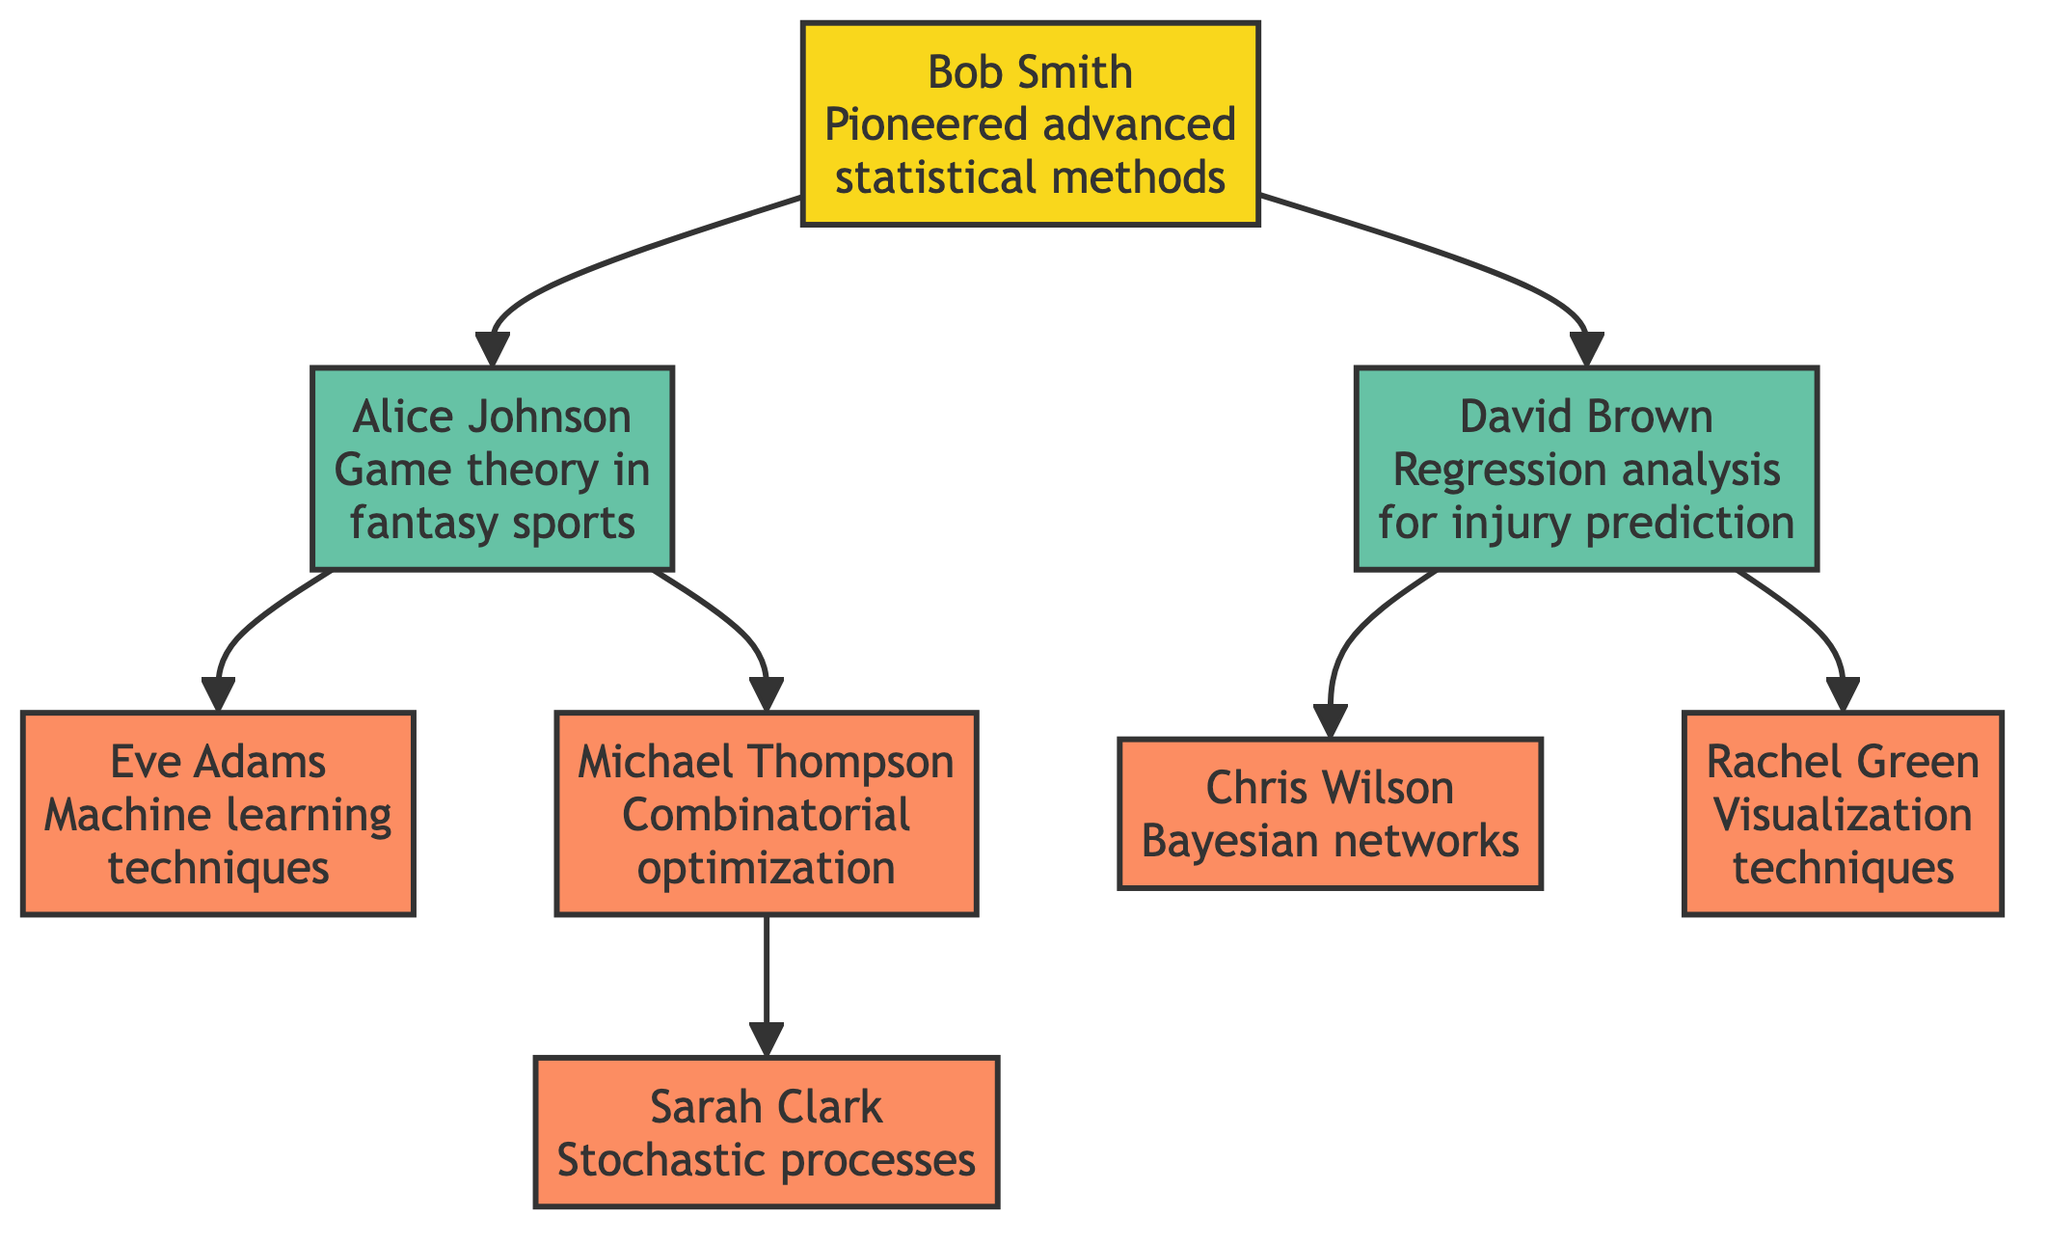What is the primary contribution of Alice Johnson? Alice Johnson is noted for authoring a widely-referenced playbook on game theory in fantasy sports.
Answer: Game theory in fantasy sports How many mentees does Bob Smith have? Bob Smith mentors two analysts: Alice Johnson and David Brown. Thus, he has a total of two mentees.
Answer: 2 Who developed models to forecast athlete injury probabilities? The diagram shows that David Brown specialized in regression analysis for injury prediction, indicating he developed these models.
Answer: David Brown What type of techniques did Eve Adams integrate into her predictions? Eve Adams is known for integrating machine learning techniques into her fantasy football predictions.
Answer: Machine learning techniques Which analyst focused on optimal lineup combinations and what method did they use? Michael Thompson focused on optimal lineup combinations using combinatorial optimization methods as indicated in the diagram.
Answer: Combinatorial optimization How many analysts did Alice Johnson mentor? Alice Johnson mentored two analysts: Eve Adams and Michael Thompson, as per the relationships shown in the diagram.
Answer: 2 What kind of analysis did Chris Wilson implement for decision making? The diagram indicates that Chris Wilson implemented Bayesian networks for fantasy football decision making.
Answer: Bayesian networks Who are the two analysts mentored by Bob Smith? Bob Smith mentored Alice Johnson and David Brown, which can be traced back through the directed lines in the diagram.
Answer: Alice Johnson, David Brown Which analyst introduced Monte Carlo simulations? The diagram specifies that Bob Smith introduced Monte Carlo simulations to predict player performance.
Answer: Bob Smith What is the impact of Sarah Clark's work? Sarah Clark's work advanced the understanding of randomness and variability in player performance, as stated in her impact description.
Answer: Randomness and variability in player performance 